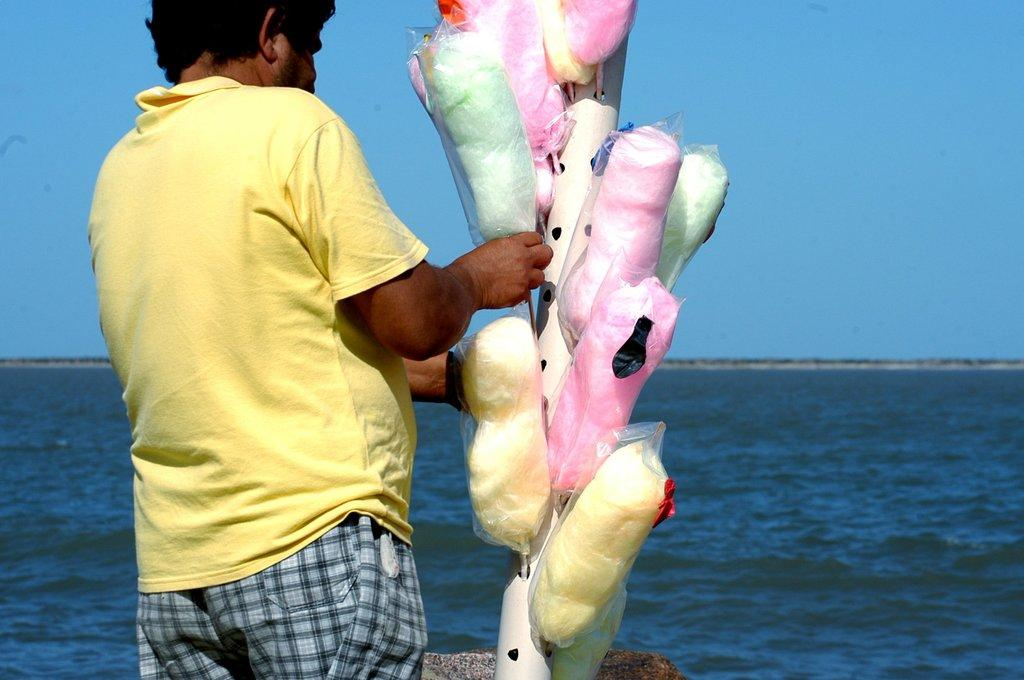What is the main subject of the image? There is a man standing in the center of the image. What is the man holding in the image? The man is holding a cotton candy. What can be seen in the background of the image? There is water visible in the background of the image. What is visible at the top of the image? The sky is visible at the top of the image. Where is the coach located in the image? There is no coach present in the image. What type of addition is being made to the library in the image? There is no library or addition being made in the image. 